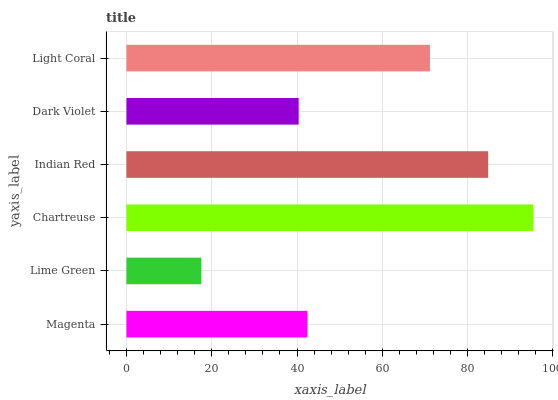Is Lime Green the minimum?
Answer yes or no. Yes. Is Chartreuse the maximum?
Answer yes or no. Yes. Is Chartreuse the minimum?
Answer yes or no. No. Is Lime Green the maximum?
Answer yes or no. No. Is Chartreuse greater than Lime Green?
Answer yes or no. Yes. Is Lime Green less than Chartreuse?
Answer yes or no. Yes. Is Lime Green greater than Chartreuse?
Answer yes or no. No. Is Chartreuse less than Lime Green?
Answer yes or no. No. Is Light Coral the high median?
Answer yes or no. Yes. Is Magenta the low median?
Answer yes or no. Yes. Is Magenta the high median?
Answer yes or no. No. Is Light Coral the low median?
Answer yes or no. No. 